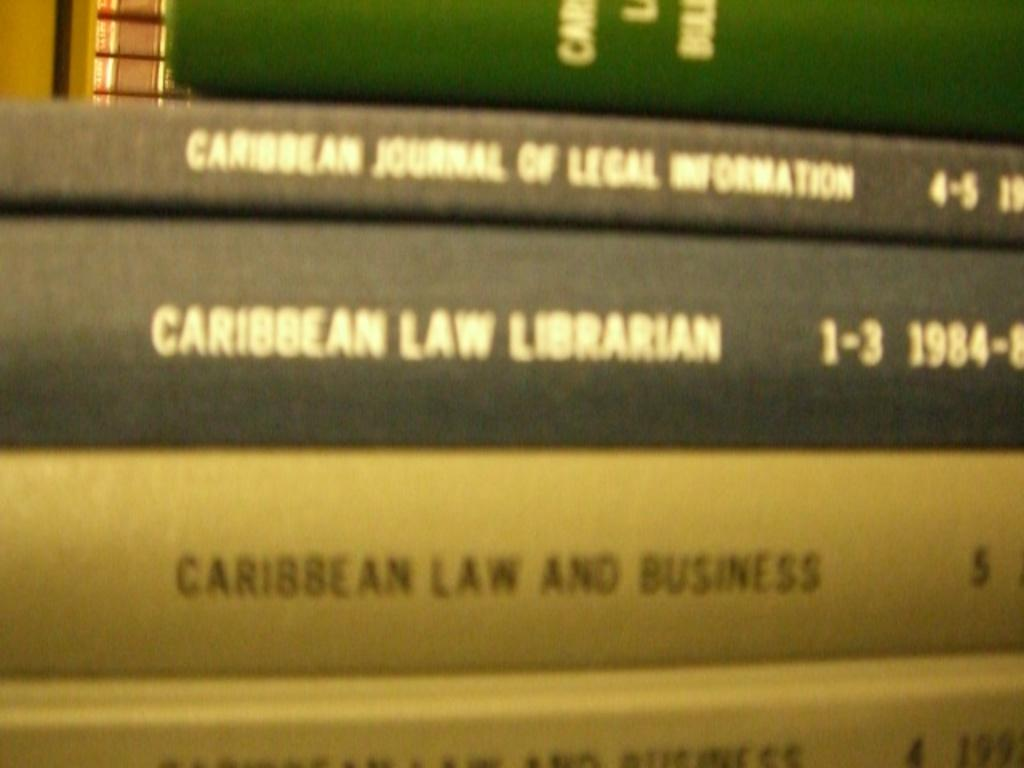<image>
Relay a brief, clear account of the picture shown. A blurry photo of book spines, one of which reads CARIBBEAN LAW LIBRARIAN. 